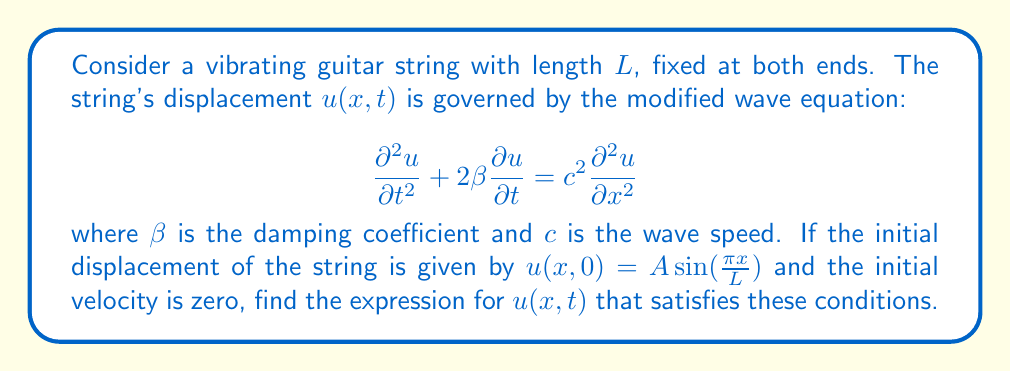What is the answer to this math problem? To solve this problem, we'll follow these steps:

1) First, we assume a solution of the form:
   $$u(x,t) = X(x)T(t)$$

2) Substituting this into the modified wave equation:
   $$X(x)T''(t) + 2\beta X(x)T'(t) = c^2 X''(x)T(t)$$

3) Separating variables:
   $$\frac{T''(t) + 2\beta T'(t)}{T(t)} = c^2 \frac{X''(x)}{X(x)} = -\lambda^2$$

4) From the spatial part, we get:
   $$X''(x) + \frac{\lambda^2}{c^2}X(x) = 0$$
   
   With boundary conditions $X(0) = X(L) = 0$, we get:
   $$X(x) = \sin(\frac{n\pi x}{L}), \lambda = \frac{n\pi c}{L}$$

5) From the temporal part:
   $$T''(t) + 2\beta T'(t) + \lambda^2 T(t) = 0$$

6) The characteristic equation is:
   $$r^2 + 2\beta r + \lambda^2 = 0$$
   
   With roots:
   $$r = -\beta \pm \sqrt{\beta^2 - \lambda^2}$$

7) For a typical guitar string, $\beta < \lambda$, so the solution is:
   $$T(t) = e^{-\beta t}(A\cos(\omega t) + B\sin(\omega t))$$
   where $\omega = \sqrt{\lambda^2 - \beta^2}$

8) The general solution is:
   $$u(x,t) = \sum_{n=1}^{\infty} e^{-\beta t}(A_n\cos(\omega_n t) + B_n\sin(\omega_n t))\sin(\frac{n\pi x}{L})$$

9) Given the initial conditions:
   $u(x,0) = A \sin(\frac{\pi x}{L})$ and $\frac{\partial u}{\partial t}(x,0) = 0$

   We can determine that $n = 1$, $A_1 = A$, and $B_1 = 0$

Therefore, the final solution is:
$$u(x,t) = Ae^{-\beta t}\cos(\omega t)\sin(\frac{\pi x}{L})$$
where $\omega = \sqrt{(\frac{\pi c}{L})^2 - \beta^2}$
Answer: $u(x,t) = Ae^{-\beta t}\cos(\omega t)\sin(\frac{\pi x}{L})$, $\omega = \sqrt{(\frac{\pi c}{L})^2 - \beta^2}$ 